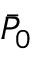<formula> <loc_0><loc_0><loc_500><loc_500>\bar { P } _ { 0 }</formula> 